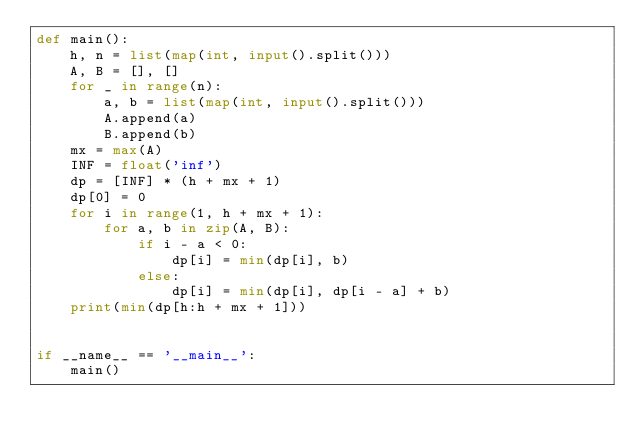Convert code to text. <code><loc_0><loc_0><loc_500><loc_500><_Python_>def main():
    h, n = list(map(int, input().split()))
    A, B = [], []
    for _ in range(n):
        a, b = list(map(int, input().split()))
        A.append(a)
        B.append(b)
    mx = max(A)
    INF = float('inf')
    dp = [INF] * (h + mx + 1)
    dp[0] = 0
    for i in range(1, h + mx + 1):
        for a, b in zip(A, B):
            if i - a < 0:
                dp[i] = min(dp[i], b)
            else:
                dp[i] = min(dp[i], dp[i - a] + b)
    print(min(dp[h:h + mx + 1]))


if __name__ == '__main__':
    main()
</code> 